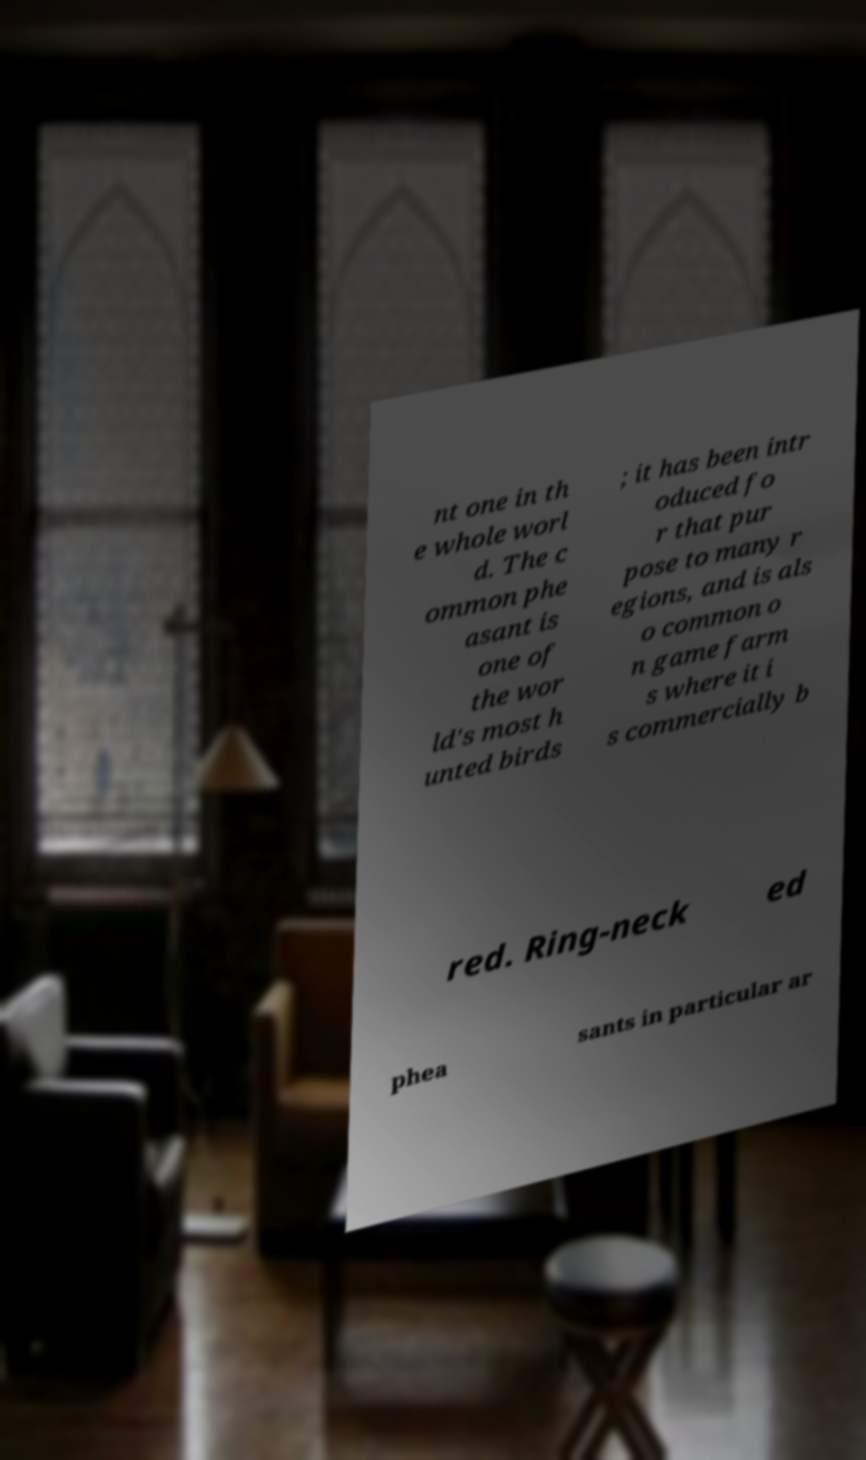Can you accurately transcribe the text from the provided image for me? nt one in th e whole worl d. The c ommon phe asant is one of the wor ld's most h unted birds ; it has been intr oduced fo r that pur pose to many r egions, and is als o common o n game farm s where it i s commercially b red. Ring-neck ed phea sants in particular ar 